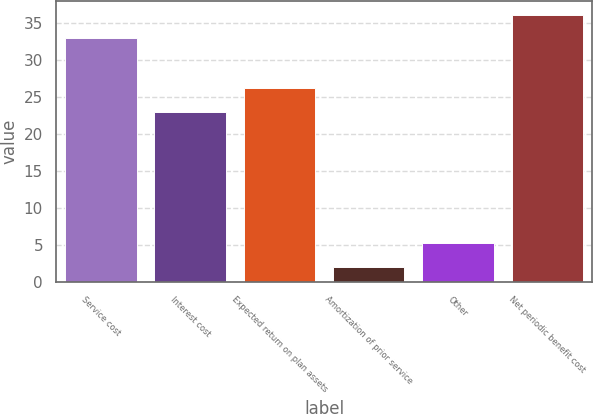Convert chart to OTSL. <chart><loc_0><loc_0><loc_500><loc_500><bar_chart><fcel>Service cost<fcel>Interest cost<fcel>Expected return on plan assets<fcel>Amortization of prior service<fcel>Other<fcel>Net periodic benefit cost<nl><fcel>33<fcel>23<fcel>26.2<fcel>2<fcel>5.2<fcel>36.2<nl></chart> 